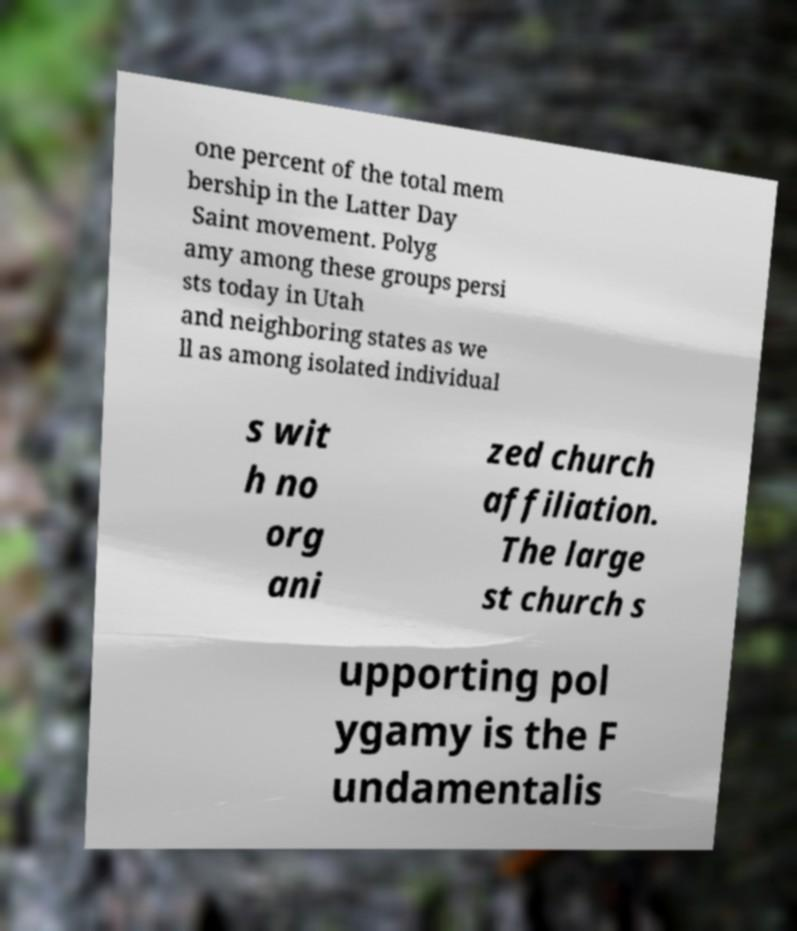Please identify and transcribe the text found in this image. one percent of the total mem bership in the Latter Day Saint movement. Polyg amy among these groups persi sts today in Utah and neighboring states as we ll as among isolated individual s wit h no org ani zed church affiliation. The large st church s upporting pol ygamy is the F undamentalis 